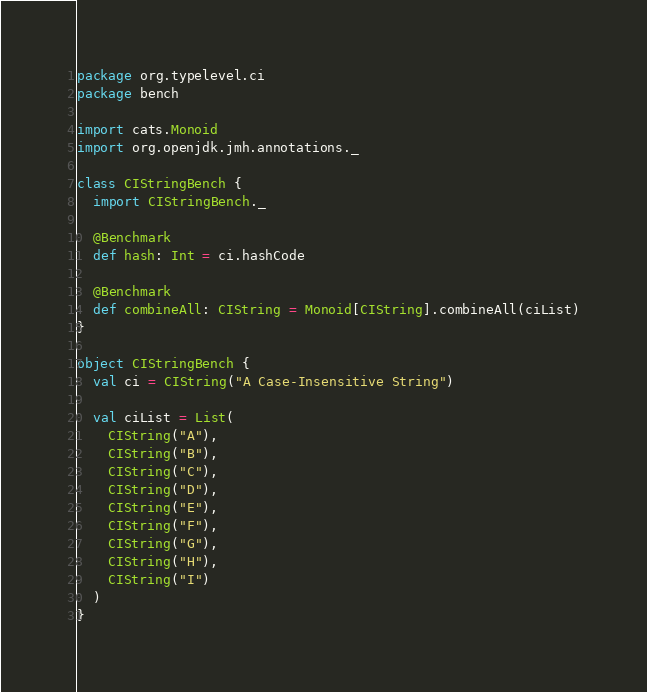Convert code to text. <code><loc_0><loc_0><loc_500><loc_500><_Scala_>package org.typelevel.ci
package bench

import cats.Monoid
import org.openjdk.jmh.annotations._

class CIStringBench {
  import CIStringBench._

  @Benchmark
  def hash: Int = ci.hashCode

  @Benchmark
  def combineAll: CIString = Monoid[CIString].combineAll(ciList)
}

object CIStringBench {
  val ci = CIString("A Case-Insensitive String")

  val ciList = List(
    CIString("A"),
    CIString("B"),
    CIString("C"),
    CIString("D"),
    CIString("E"),
    CIString("F"),
    CIString("G"),
    CIString("H"),
    CIString("I")
  )
}
</code> 